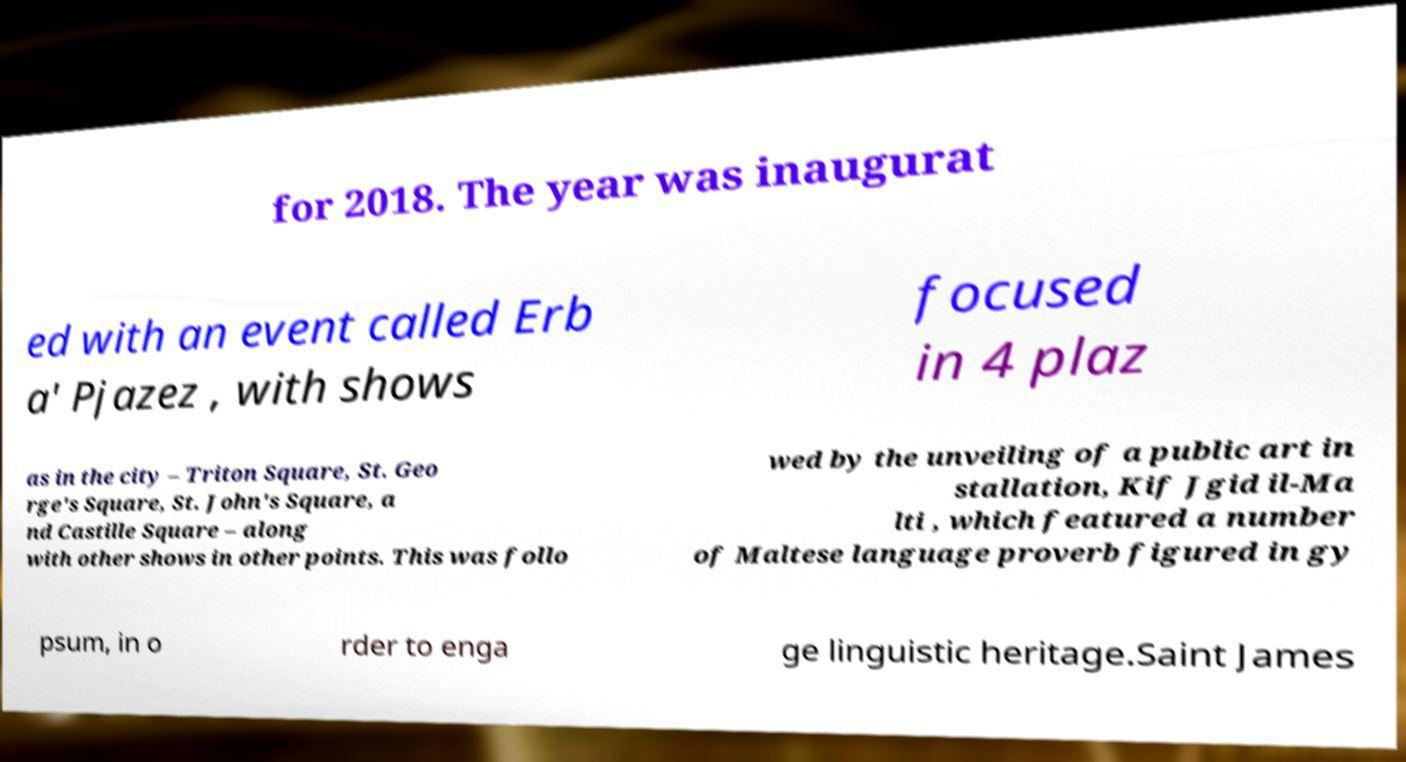There's text embedded in this image that I need extracted. Can you transcribe it verbatim? for 2018. The year was inaugurat ed with an event called Erb a' Pjazez , with shows focused in 4 plaz as in the city – Triton Square, St. Geo rge's Square, St. John's Square, a nd Castille Square – along with other shows in other points. This was follo wed by the unveiling of a public art in stallation, Kif Jgid il-Ma lti , which featured a number of Maltese language proverb figured in gy psum, in o rder to enga ge linguistic heritage.Saint James 